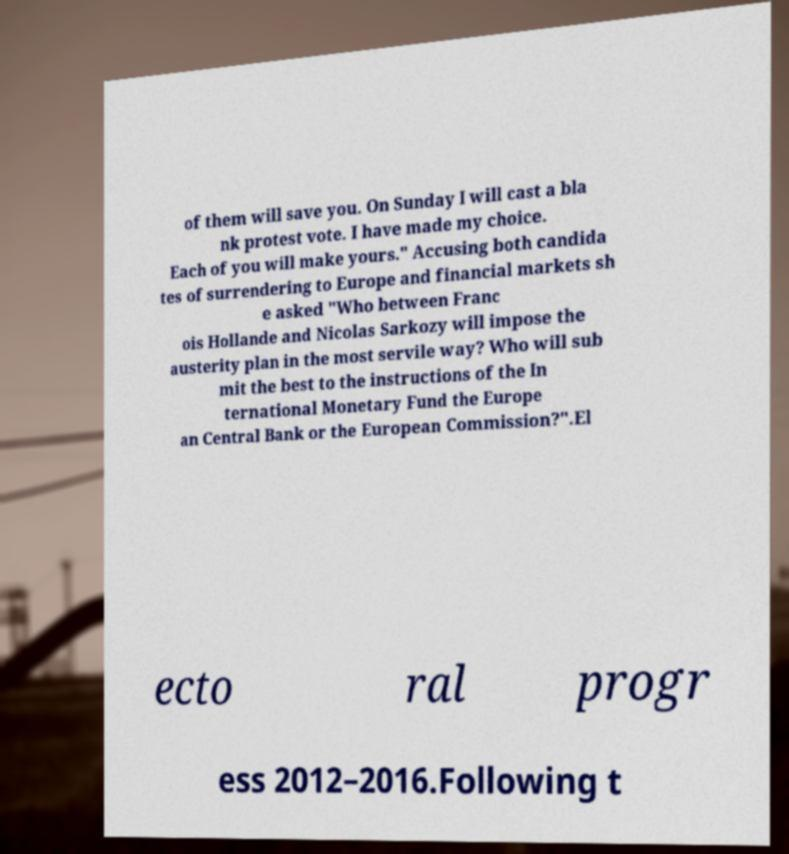Could you assist in decoding the text presented in this image and type it out clearly? of them will save you. On Sunday I will cast a bla nk protest vote. I have made my choice. Each of you will make yours." Accusing both candida tes of surrendering to Europe and financial markets sh e asked "Who between Franc ois Hollande and Nicolas Sarkozy will impose the austerity plan in the most servile way? Who will sub mit the best to the instructions of the In ternational Monetary Fund the Europe an Central Bank or the European Commission?".El ecto ral progr ess 2012–2016.Following t 